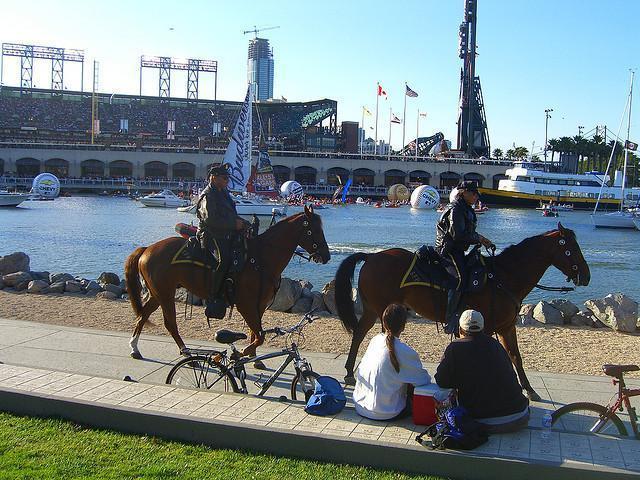How many horses are there?
Give a very brief answer. 2. How many bicycles are there?
Give a very brief answer. 2. How many horses can be seen?
Give a very brief answer. 2. How many people are there?
Give a very brief answer. 4. 